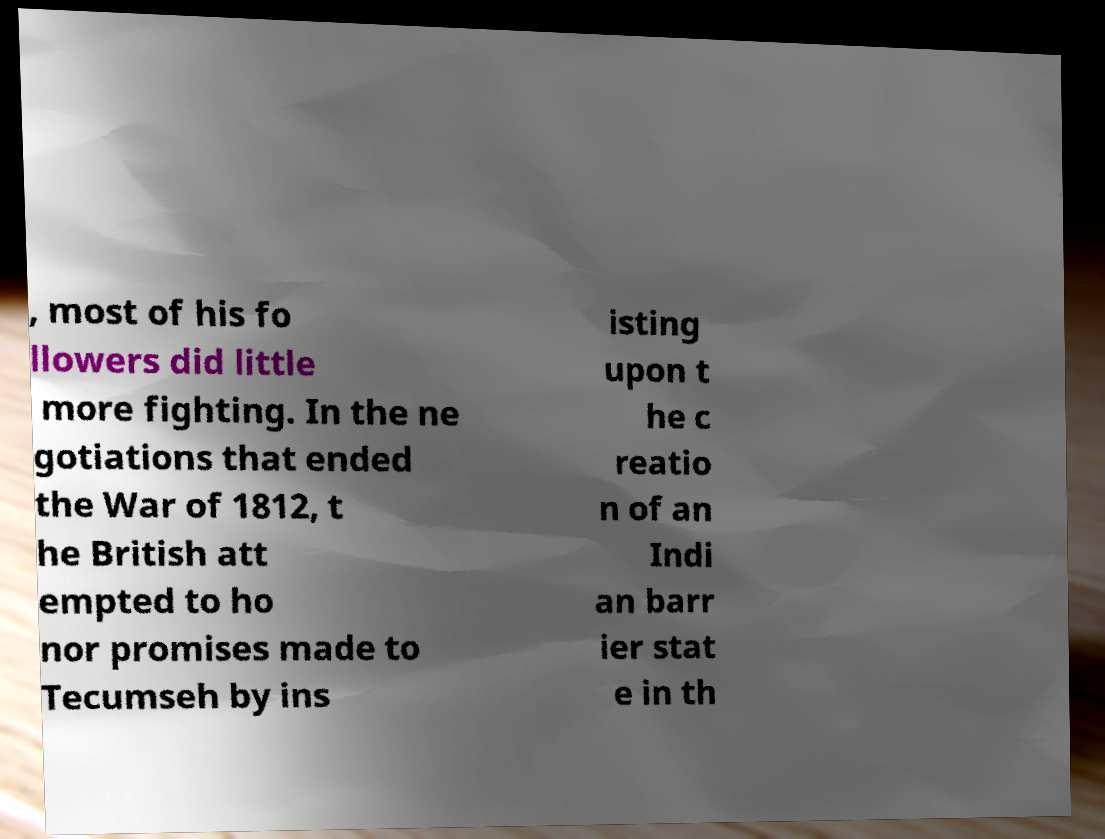Please identify and transcribe the text found in this image. , most of his fo llowers did little more fighting. In the ne gotiations that ended the War of 1812, t he British att empted to ho nor promises made to Tecumseh by ins isting upon t he c reatio n of an Indi an barr ier stat e in th 